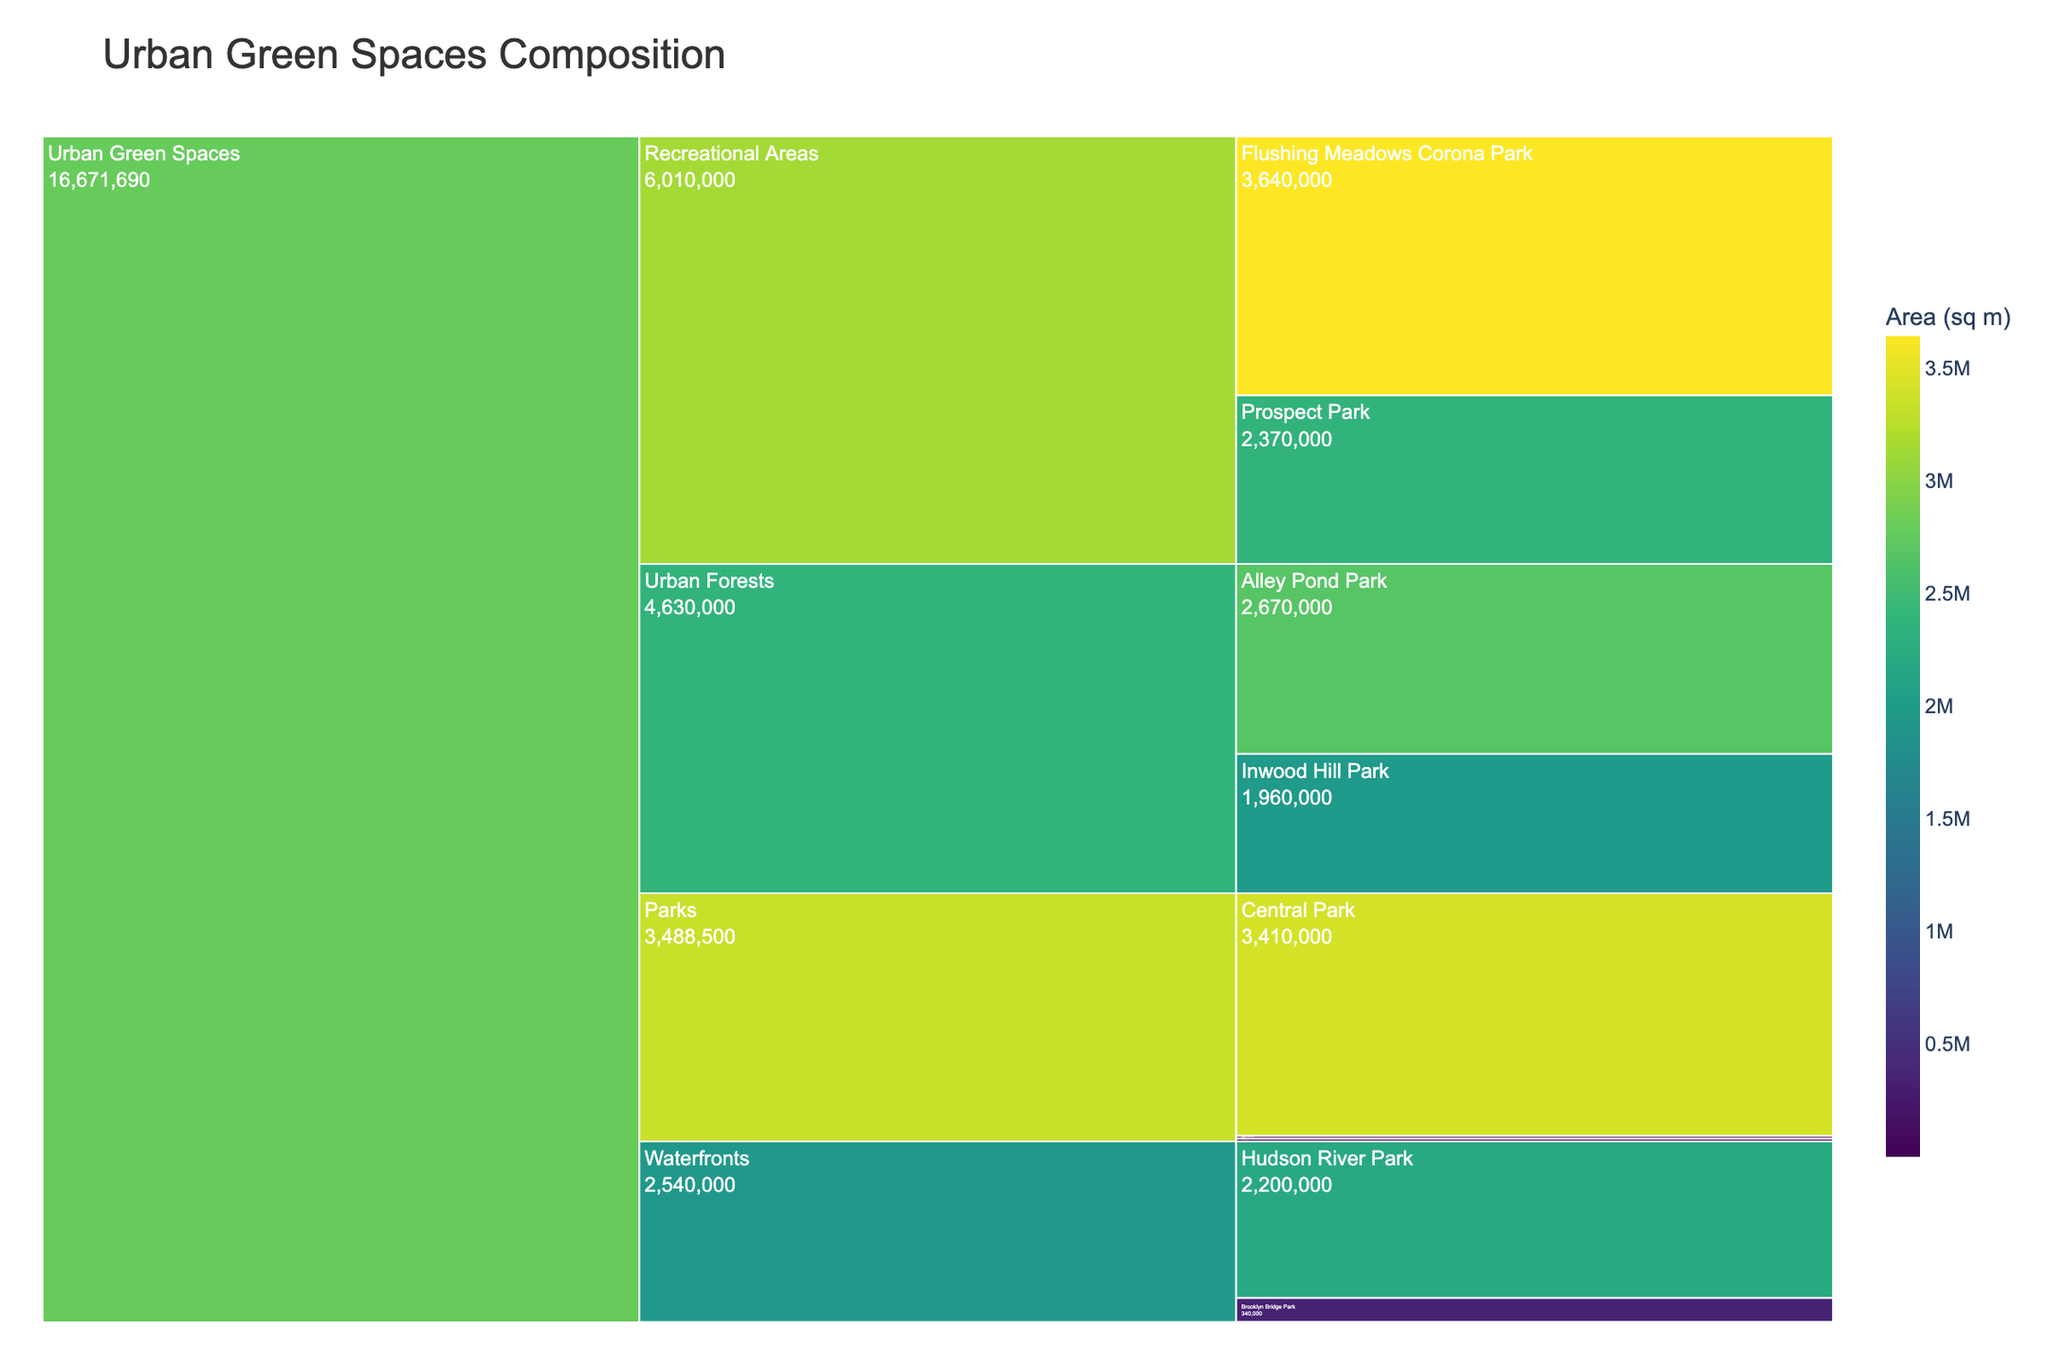What is the largest type of urban green space in terms of area? By looking at the largest segments in the icicle chart, identify the type with the highest value. The largest type of urban green space is "Flushing Meadows Corona Park" under the "Recreational Areas" category with an area of 3,640,000 sq m.
Answer: Flushing Meadows Corona Park What is the color scale used to represent the area of the green spaces? The title of the color scale and the gradient of colors can be seen in the color bar. The color scale used to represent the area is "Viridis," which ranges from dark green to light yellow.
Answer: Viridis Which subcategory has the most entries in the icicle chart? By counting the segments under each subcategory, determine which has the most. The "Parks" subcategory has three entries: Central Park, Washington Square Park, and Bryant Park.
Answer: Parks What is the combined area of all the community gardens? Sum the areas of Liz Christy Garden (1,000 sq m) and Clinton Community Garden (1,200 sq m). The combined area is 1,000 + 1,200 = 2,200 sq m.
Answer: 2,200 sq m How does the area of Hudson River Park compare to Central Park? Find the areas of both parks and compare them. Hudson River Park has 2,200,000 sq m and Central Park has 3,410,000 sq m. Therefore, Central Park is larger.
Answer: Central Park is larger What is the smallest pocket park by area? By identifying the smallest segment under the "Pocket Parks" subcategory, determine the type and its value. Paley Park is the smallest pocket park, with an area of 390 sq m.
Answer: Paley Park Which subcategory has the largest total area? Sum the areas for each subcategory and compare them. "Recreational Areas" has the largest total area: Prospect Park (2,370,000 sq m) + Flushing Meadows Corona Park (3,640,000 sq m) = 6,010,000 sq m.
Answer: Recreational Areas Between "Urban Forests" and "Waterfronts," which has a greater total area? Sum the areas for "Urban Forests" (Inwood Hill Park: 1,960,000 + Alley Pond Park: 2,670,000) and for "Waterfronts" (Brooklyn Bridge Park: 340,000 + Hudson River Park: 2,200,000). Compare the sums: "Urban Forests" = 4,630,000 sq m and "Waterfronts" = 2,540,000 sq m. "Urban Forests" have a greater total area.
Answer: Urban Forests What percentage of the total area do parks (subcategory) occupy? Sum the areas of all parks and divide by the total area, then multiply by 100. The total area for parks is Central Park (3,410,000 sq m) + Washington Square Park (39,500 sq m) + Bryant Park (39,000 sq m) = 3,488,500 sq m. The total area of all green spaces is 18,510,090 sq m. So, (3,488,500 / 18,510,090) * 100 = 18.85%.
Answer: 18.85% What is the title of the icicle chart? Locate and read the title displayed at the top of the icicle chart. The title of the chart is "Urban Green Spaces Composition."
Answer: Urban Green Spaces Composition 